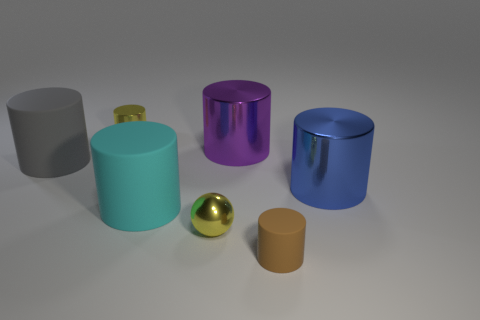Subtract all cyan cylinders. How many cylinders are left? 5 Subtract all purple cylinders. How many cylinders are left? 5 Add 1 tiny metallic cylinders. How many objects exist? 8 Subtract all balls. How many objects are left? 6 Subtract all red cylinders. Subtract all brown balls. How many cylinders are left? 6 Add 5 tiny yellow shiny things. How many tiny yellow shiny things exist? 7 Subtract 0 brown blocks. How many objects are left? 7 Subtract all big blue metallic objects. Subtract all tiny brown rubber objects. How many objects are left? 5 Add 7 yellow cylinders. How many yellow cylinders are left? 8 